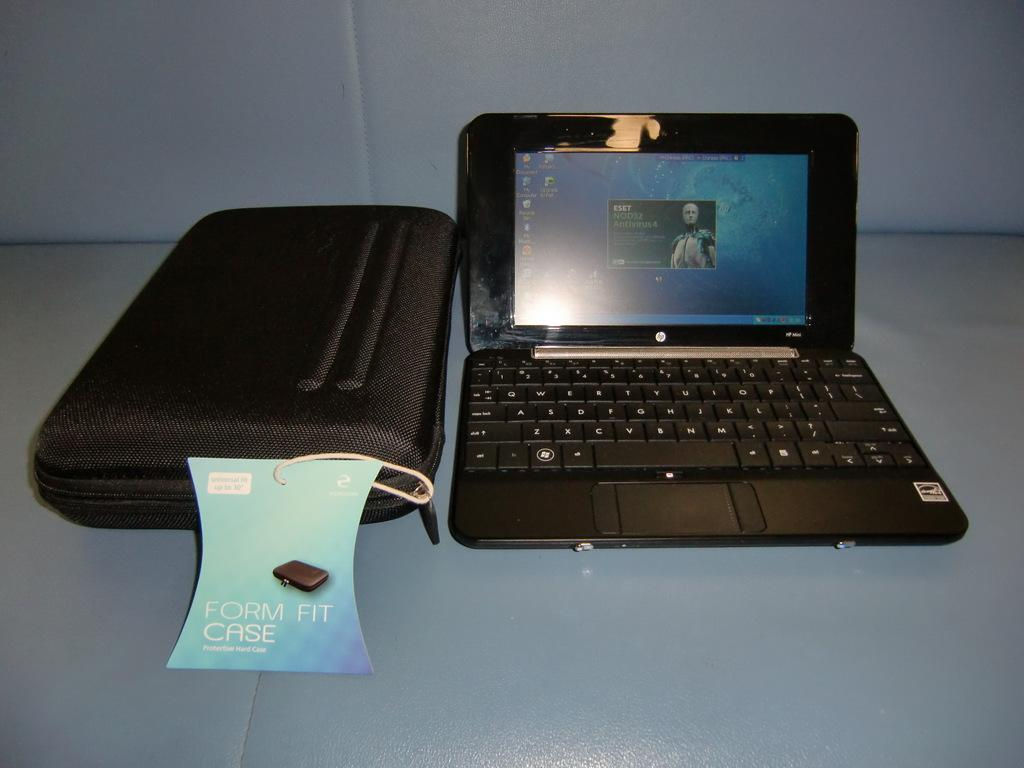<image>
Describe the image concisely. The black laptop has a k key next to the j key 